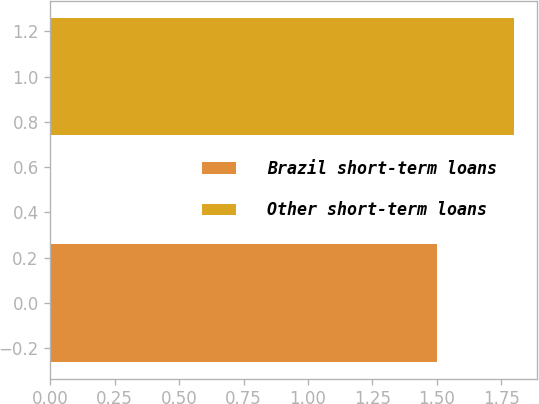Convert chart to OTSL. <chart><loc_0><loc_0><loc_500><loc_500><bar_chart><fcel>Brazil short-term loans<fcel>Other short-term loans<nl><fcel>1.5<fcel>1.8<nl></chart> 